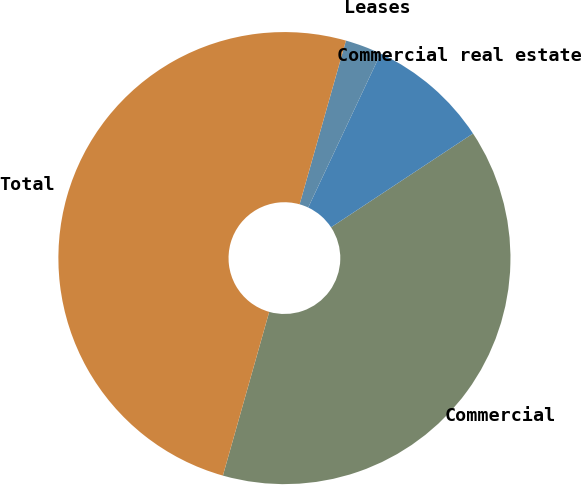Convert chart to OTSL. <chart><loc_0><loc_0><loc_500><loc_500><pie_chart><fcel>Commercial<fcel>Commercial real estate<fcel>Leases<fcel>Total<nl><fcel>38.68%<fcel>8.71%<fcel>2.61%<fcel>50.0%<nl></chart> 